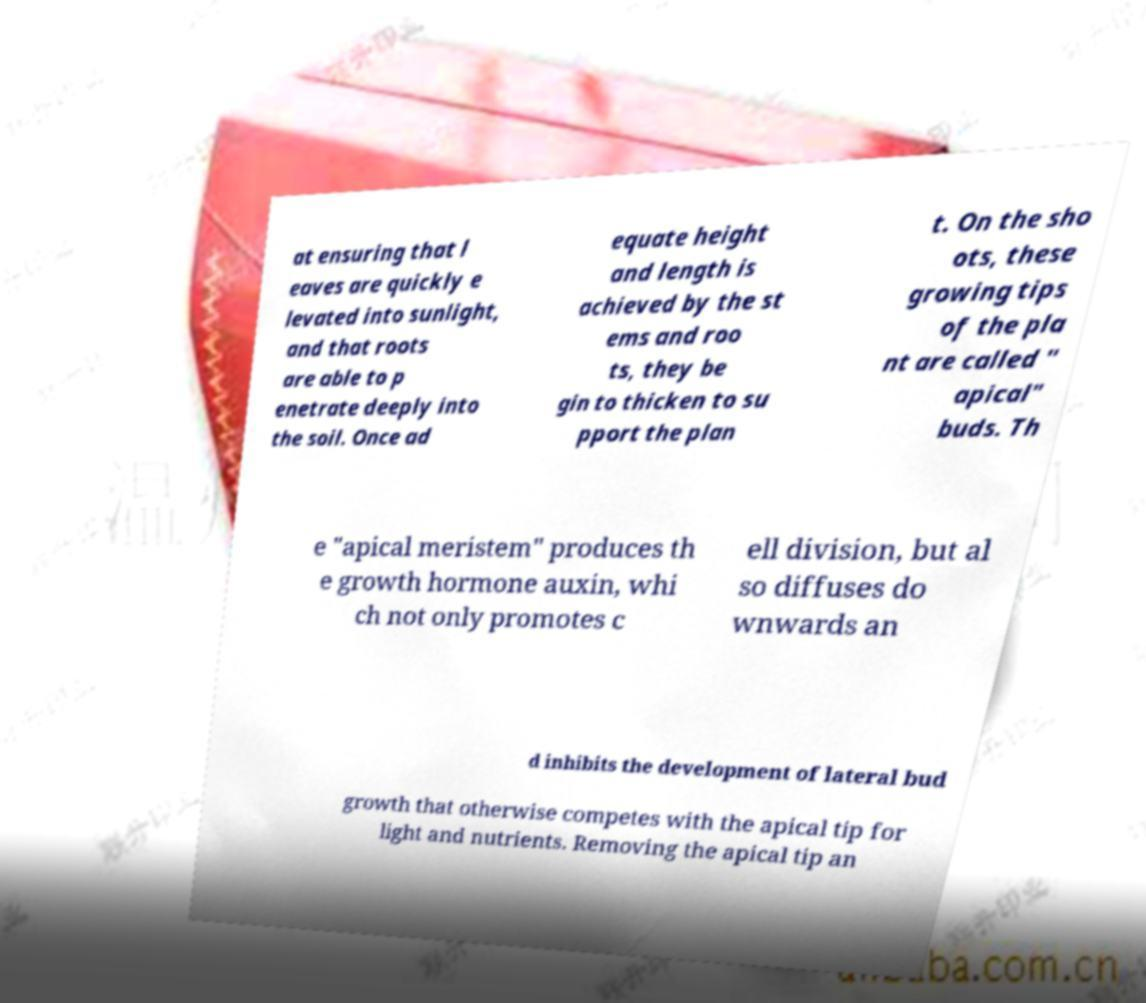Please read and relay the text visible in this image. What does it say? at ensuring that l eaves are quickly e levated into sunlight, and that roots are able to p enetrate deeply into the soil. Once ad equate height and length is achieved by the st ems and roo ts, they be gin to thicken to su pport the plan t. On the sho ots, these growing tips of the pla nt are called " apical" buds. Th e "apical meristem" produces th e growth hormone auxin, whi ch not only promotes c ell division, but al so diffuses do wnwards an d inhibits the development of lateral bud growth that otherwise competes with the apical tip for light and nutrients. Removing the apical tip an 